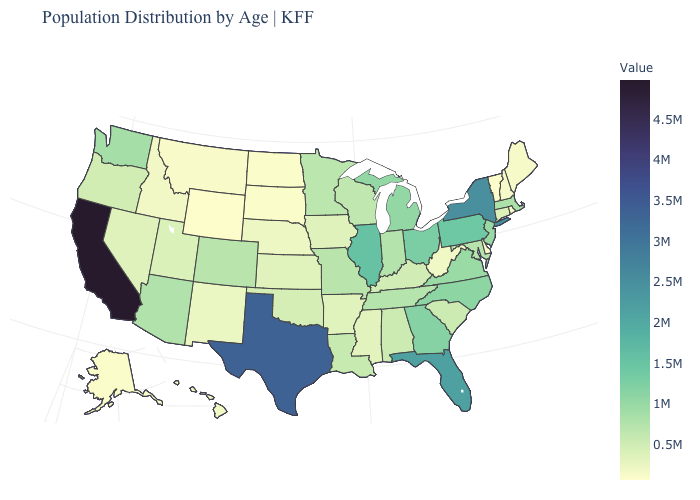Among the states that border Utah , does New Mexico have the lowest value?
Give a very brief answer. No. Among the states that border North Dakota , does South Dakota have the lowest value?
Be succinct. Yes. Does the map have missing data?
Give a very brief answer. No. Which states have the lowest value in the MidWest?
Short answer required. North Dakota. Does Illinois have the highest value in the MidWest?
Give a very brief answer. Yes. 